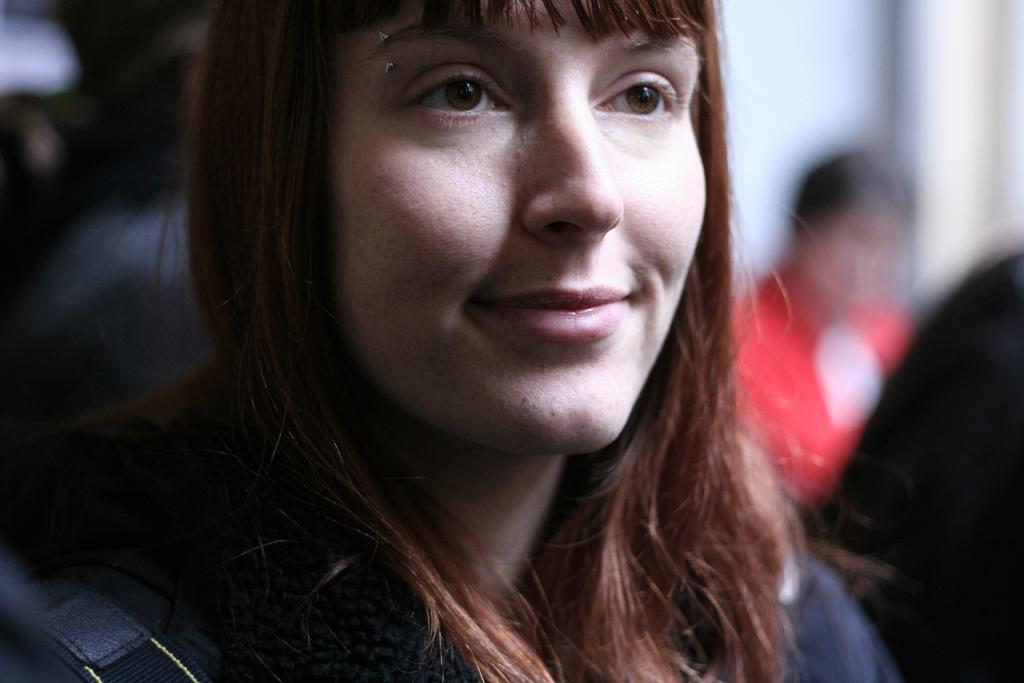Who is present in the image? There is a woman in the image. What is the woman doing in the image? The woman is smiling. What type of egg is the woman holding in the image? There is no egg present in the image; the woman is simply smiling. 